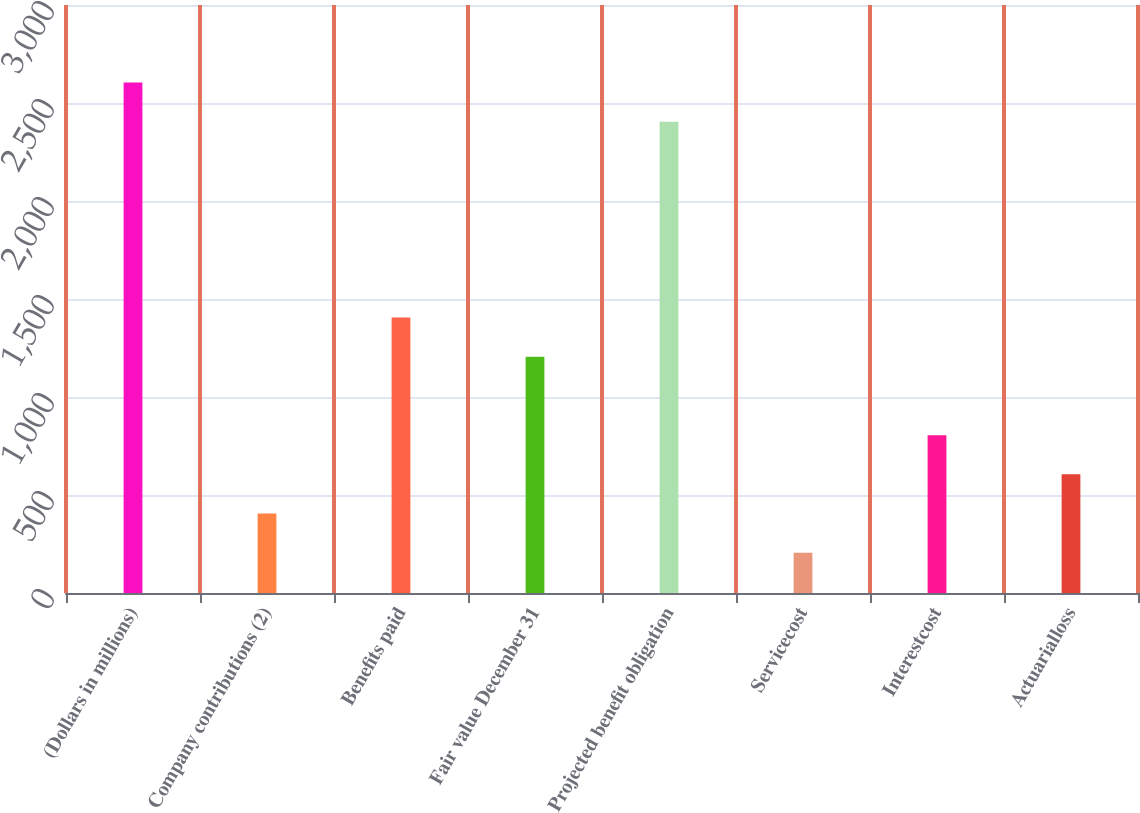<chart> <loc_0><loc_0><loc_500><loc_500><bar_chart><fcel>(Dollars in millions)<fcel>Company contributions (2)<fcel>Benefits paid<fcel>Fair value December 31<fcel>Projected benefit obligation<fcel>Servicecost<fcel>Interestcost<fcel>Actuarialloss<nl><fcel>2604.85<fcel>405.4<fcel>1405.15<fcel>1205.2<fcel>2404.9<fcel>205.45<fcel>805.3<fcel>605.35<nl></chart> 